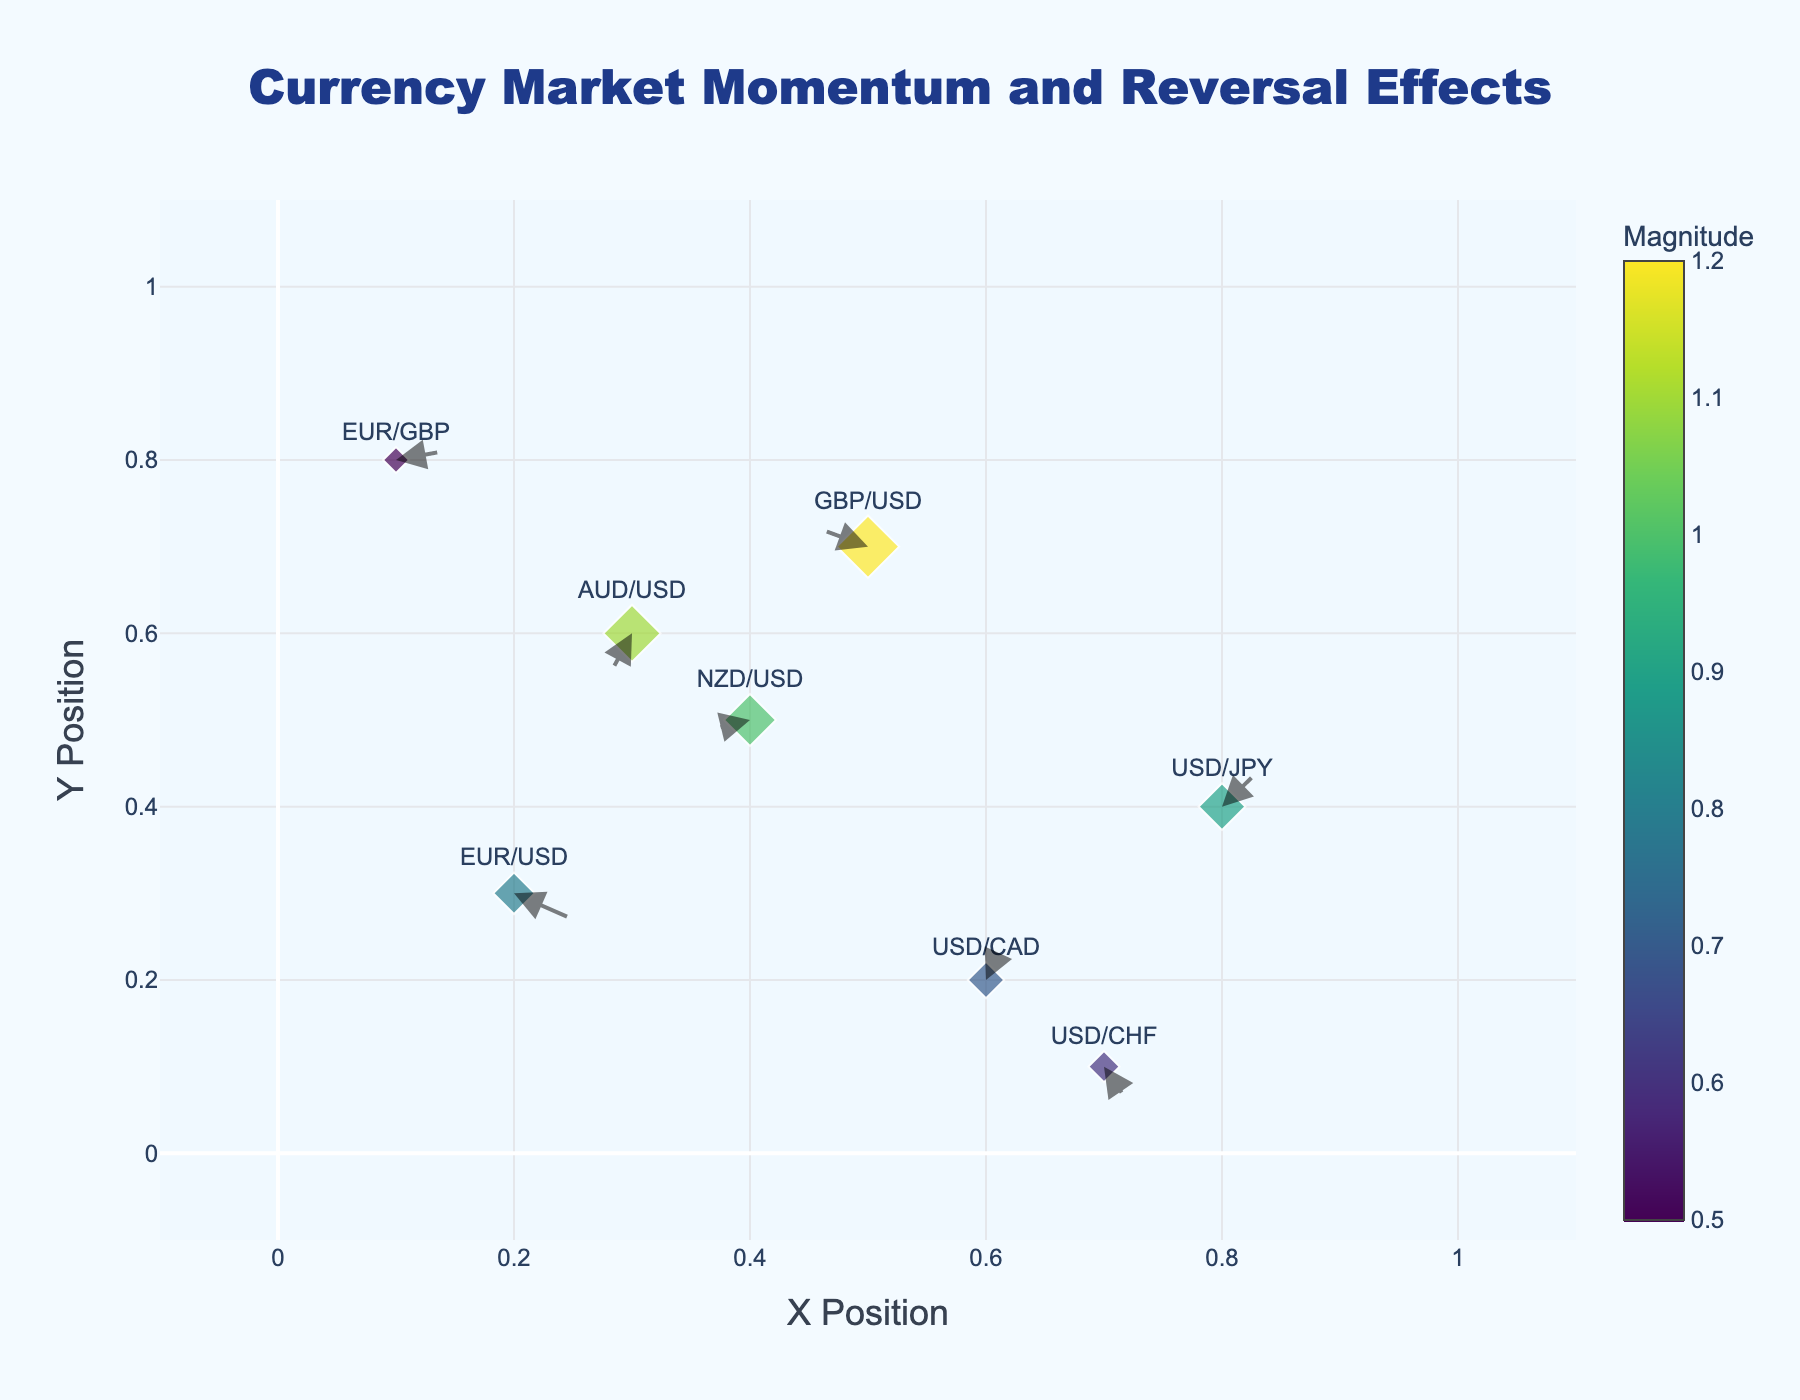what is the title of the figure? The title is located at the top of the figure. Read it to know what the graph represents.
Answer: Currency Market Momentum and Reversal Effects how many currency pairs are represented on the plot? Each marker corresponds to a currency pair, and each one has a label. Count the number of labeled markers.
Answer: 8 what does the magnitude of the arrows indicate? The color and size of the markers are related to the magnitude. It measures the influence or strength of a particular currency pair. The larger and darker the marker, the greater the influence.
Answer: Influence or strength which currency pair has the largest magnitude? Check the marker sizes and the color scale to identify the pair with the largest magnitude.
Answer: GBP/USD which currency pair is showing a negative reversal along both x and y axes? Look at the directions of the arrows. Arrows pointing towards the left and downwards represent a negative reversal on both axes.
Answer: AUD/USD how is the direction of currency pairs indicated on the plot? The direction of each arrow represents the direction of movement for each currency pair. Arrows pointing to the right indicate positive movement on the x-axis, while upward arrows indicate positive movement on the y-axis.
Answer: By arrow direction what are the x- and y-positions of the USD/JPY pair? Locate the USD/JPY label and read its x and y coordinates from the plot's axes.
Answer: X=0.8, Y=0.4 which currency pair has the smallest magnitude, and what is its value? Check the color scale and marker sizes to find the pair with the smallest marker.
Answer: USD/CHF, Magnitude=0.6 compare the movement direction of EUR/USD and GBP/USD pairs. What’s the result? Look at the arrows for both pairs. EUR/USD’s arrow is small and points slightly to the left and downward, while GBP/USD points to the left and upward but with a stronger influence.
Answer: EUR/USD: Left and downward; GBP/USD: Left and upward is there any currency pair showing a positive reversal along both x and y axes? Find arrows pointing towards the right and upward. If there are no such arrows, then no currency pair shows a positive reversal along both axes.
Answer: No 